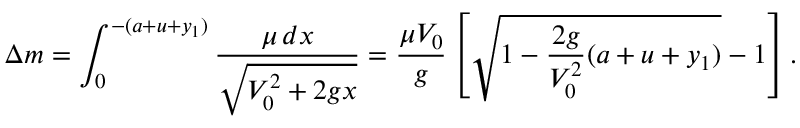Convert formula to latex. <formula><loc_0><loc_0><loc_500><loc_500>\Delta m = \int _ { 0 } ^ { - ( a + u + y _ { 1 } ) } \frac { \mu \, d x } { \sqrt { V _ { 0 } ^ { 2 } + 2 g x } } = \frac { \mu V _ { 0 } } { g } \left [ \sqrt { 1 - \frac { 2 g } { V _ { 0 } ^ { 2 } } ( a + u + y _ { 1 } ) } - 1 \right ] .</formula> 